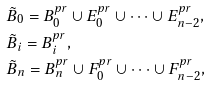<formula> <loc_0><loc_0><loc_500><loc_500>& \tilde { B } _ { 0 } = B _ { 0 } ^ { p r } \cup E _ { 0 } ^ { p r } \cup \cdots \cup E _ { n - 2 } ^ { p r } , \\ & \tilde { B } _ { i } = B _ { i } ^ { p r } , \\ & \tilde { B } _ { n } = B _ { n } ^ { p r } \cup F _ { 0 } ^ { p r } \cup \cdots \cup F _ { n - 2 } ^ { p r } ,</formula> 